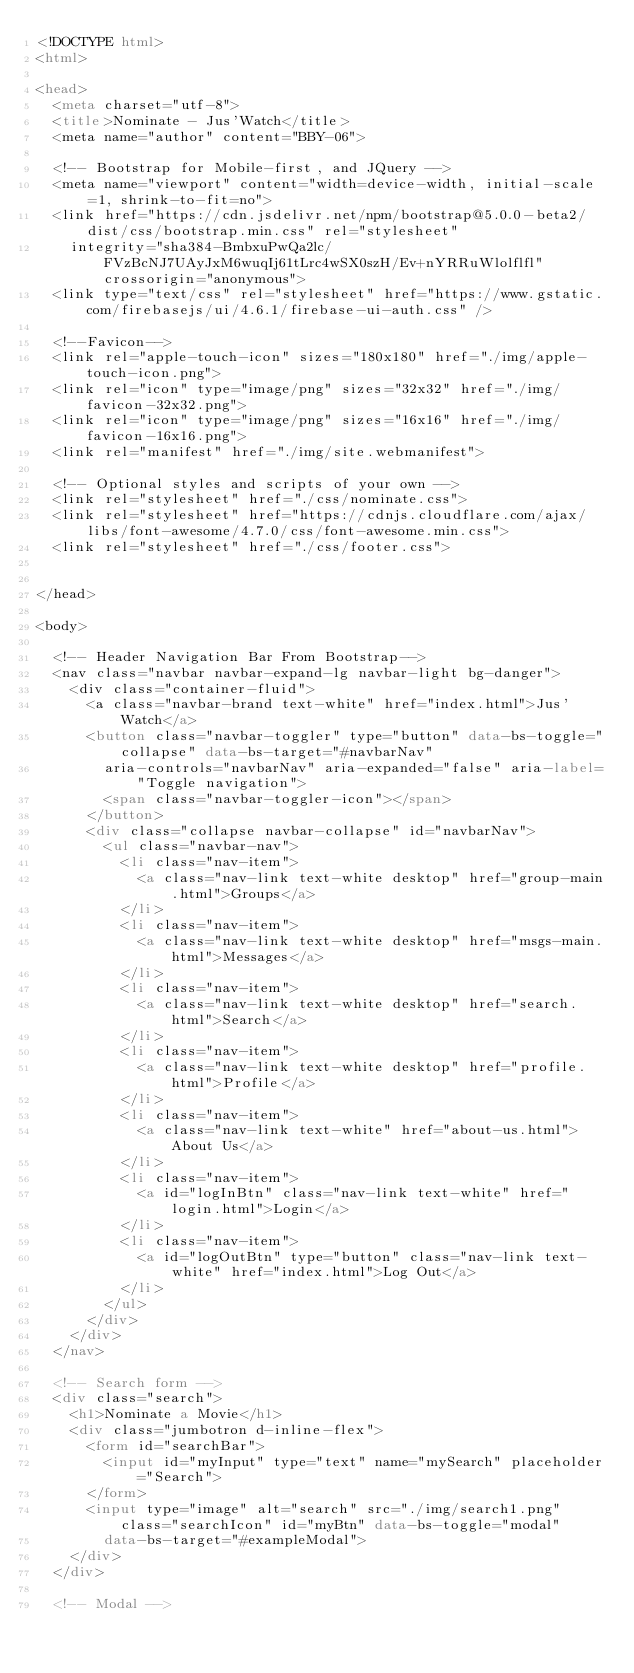<code> <loc_0><loc_0><loc_500><loc_500><_HTML_><!DOCTYPE html>
<html>

<head>
  <meta charset="utf-8">
  <title>Nominate - Jus'Watch</title>
  <meta name="author" content="BBY-06">

  <!-- Bootstrap for Mobile-first, and JQuery -->
  <meta name="viewport" content="width=device-width, initial-scale=1, shrink-to-fit=no">
  <link href="https://cdn.jsdelivr.net/npm/bootstrap@5.0.0-beta2/dist/css/bootstrap.min.css" rel="stylesheet"
    integrity="sha384-BmbxuPwQa2lc/FVzBcNJ7UAyJxM6wuqIj61tLrc4wSX0szH/Ev+nYRRuWlolflfl" crossorigin="anonymous">
  <link type="text/css" rel="stylesheet" href="https://www.gstatic.com/firebasejs/ui/4.6.1/firebase-ui-auth.css" />

  <!--Favicon-->
  <link rel="apple-touch-icon" sizes="180x180" href="./img/apple-touch-icon.png">
  <link rel="icon" type="image/png" sizes="32x32" href="./img/favicon-32x32.png">
  <link rel="icon" type="image/png" sizes="16x16" href="./img/favicon-16x16.png">
  <link rel="manifest" href="./img/site.webmanifest">

  <!-- Optional styles and scripts of your own -->
  <link rel="stylesheet" href="./css/nominate.css">
  <link rel="stylesheet" href="https://cdnjs.cloudflare.com/ajax/libs/font-awesome/4.7.0/css/font-awesome.min.css">
  <link rel="stylesheet" href="./css/footer.css">


</head>

<body>

  <!-- Header Navigation Bar From Bootstrap-->
  <nav class="navbar navbar-expand-lg navbar-light bg-danger">
    <div class="container-fluid">
      <a class="navbar-brand text-white" href="index.html">Jus'Watch</a>
      <button class="navbar-toggler" type="button" data-bs-toggle="collapse" data-bs-target="#navbarNav"
        aria-controls="navbarNav" aria-expanded="false" aria-label="Toggle navigation">
        <span class="navbar-toggler-icon"></span>
      </button>
      <div class="collapse navbar-collapse" id="navbarNav">
        <ul class="navbar-nav">
          <li class="nav-item">
            <a class="nav-link text-white desktop" href="group-main.html">Groups</a>
          </li>
          <li class="nav-item">
            <a class="nav-link text-white desktop" href="msgs-main.html">Messages</a>
          </li>
          <li class="nav-item">
            <a class="nav-link text-white desktop" href="search.html">Search</a>
          </li>
          <li class="nav-item">
            <a class="nav-link text-white desktop" href="profile.html">Profile</a>
          </li>
          <li class="nav-item">
            <a class="nav-link text-white" href="about-us.html">About Us</a>
          </li>
          <li class="nav-item">
            <a id="logInBtn" class="nav-link text-white" href="login.html">Login</a>
          </li>
          <li class="nav-item">
            <a id="logOutBtn" type="button" class="nav-link text-white" href="index.html">Log Out</a>
          </li>
        </ul>
      </div>
    </div>
  </nav>

  <!-- Search form -->
  <div class="search">
    <h1>Nominate a Movie</h1>
    <div class="jumbotron d-inline-flex">
      <form id="searchBar">
        <input id="myInput" type="text" name="mySearch" placeholder="Search">
      </form>
      <input type="image" alt="search" src="./img/search1.png" class="searchIcon" id="myBtn" data-bs-toggle="modal"
        data-bs-target="#exampleModal">
    </div>
  </div>

  <!-- Modal --></code> 